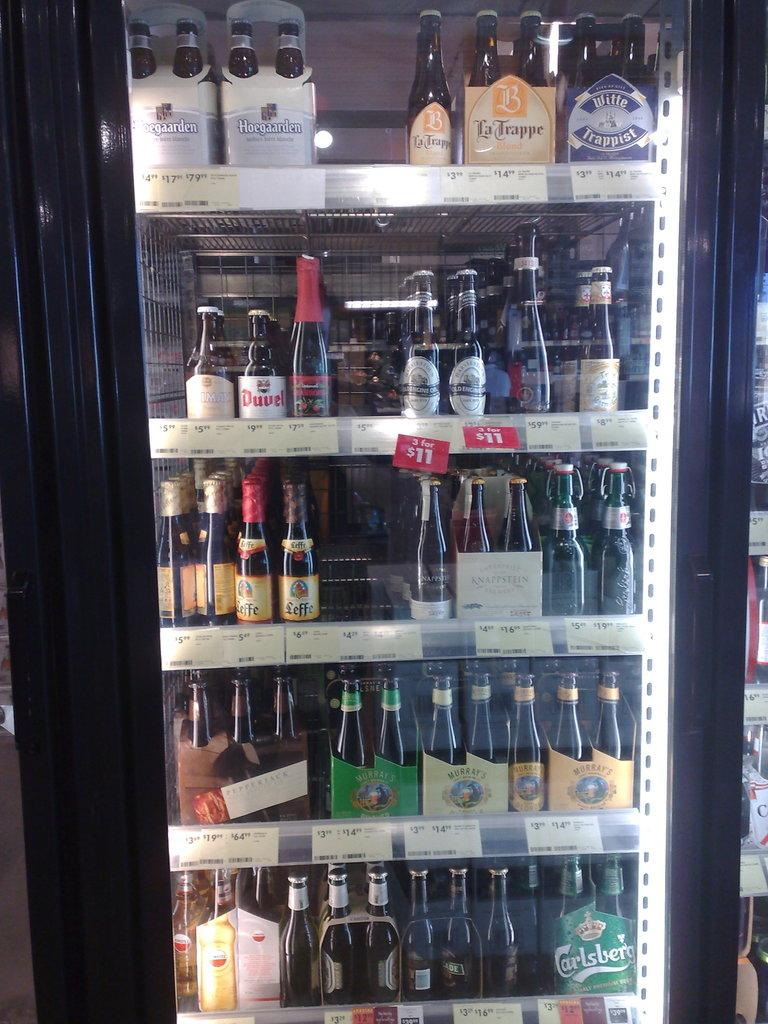What type of appliance is visible in the image? There is a refrigerator in the image. What is stored inside the refrigerator? Bottles are arranged in the shelves of the refrigerator. Can you describe the variety of bottles in the refrigerator? There are different kinds of bottles visible in the image. What type of pen is used to write on the invention in the image? There is no pen or invention present in the image; it only features a refrigerator with bottles. 